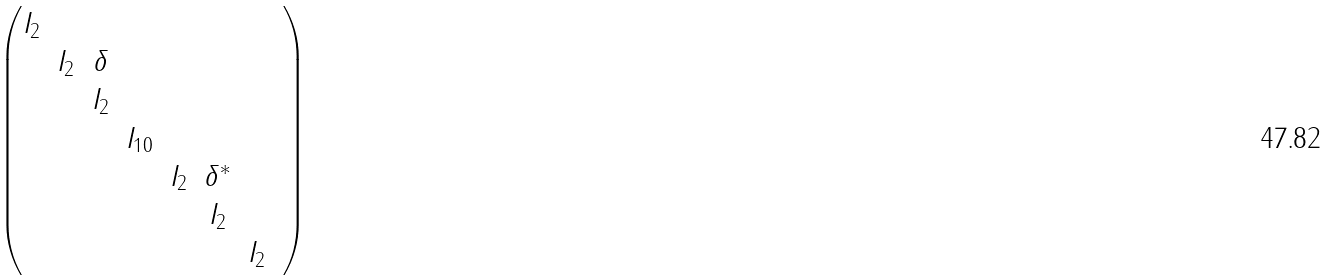<formula> <loc_0><loc_0><loc_500><loc_500>\begin{pmatrix} I _ { 2 } & & & & & & \\ & I _ { 2 } & \delta & & & & & \\ & & I _ { 2 } & & & & \\ & & & I _ { 1 0 } & & & \\ & & & & I _ { 2 } & \delta ^ { * } & \\ & & & & & I _ { 2 } & \\ & & & & & & I _ { 2 } \end{pmatrix}</formula> 